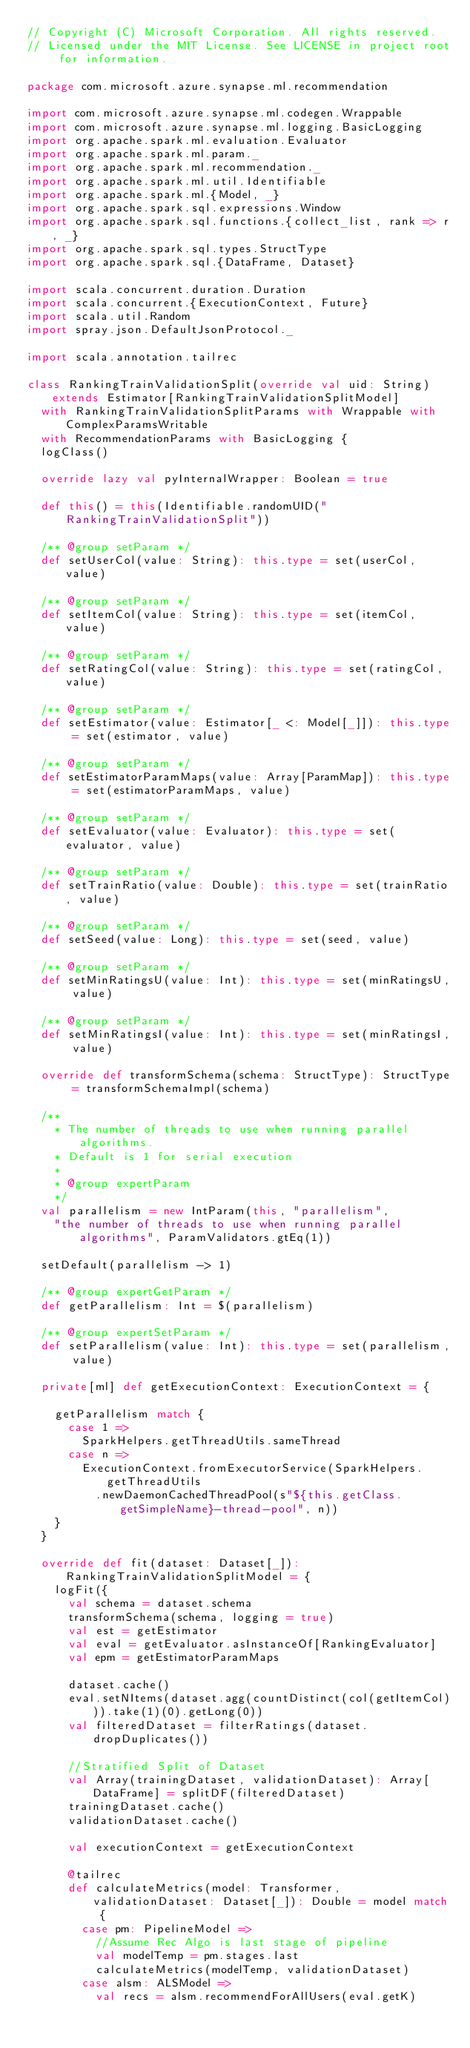Convert code to text. <code><loc_0><loc_0><loc_500><loc_500><_Scala_>// Copyright (C) Microsoft Corporation. All rights reserved.
// Licensed under the MIT License. See LICENSE in project root for information.

package com.microsoft.azure.synapse.ml.recommendation

import com.microsoft.azure.synapse.ml.codegen.Wrappable
import com.microsoft.azure.synapse.ml.logging.BasicLogging
import org.apache.spark.ml.evaluation.Evaluator
import org.apache.spark.ml.param._
import org.apache.spark.ml.recommendation._
import org.apache.spark.ml.util.Identifiable
import org.apache.spark.ml.{Model, _}
import org.apache.spark.sql.expressions.Window
import org.apache.spark.sql.functions.{collect_list, rank => r, _}
import org.apache.spark.sql.types.StructType
import org.apache.spark.sql.{DataFrame, Dataset}

import scala.concurrent.duration.Duration
import scala.concurrent.{ExecutionContext, Future}
import scala.util.Random
import spray.json.DefaultJsonProtocol._

import scala.annotation.tailrec

class RankingTrainValidationSplit(override val uid: String) extends Estimator[RankingTrainValidationSplitModel]
  with RankingTrainValidationSplitParams with Wrappable with ComplexParamsWritable
  with RecommendationParams with BasicLogging {
  logClass()

  override lazy val pyInternalWrapper: Boolean = true

  def this() = this(Identifiable.randomUID("RankingTrainValidationSplit"))

  /** @group setParam */
  def setUserCol(value: String): this.type = set(userCol, value)

  /** @group setParam */
  def setItemCol(value: String): this.type = set(itemCol, value)

  /** @group setParam */
  def setRatingCol(value: String): this.type = set(ratingCol, value)

  /** @group setParam */
  def setEstimator(value: Estimator[_ <: Model[_]]): this.type = set(estimator, value)

  /** @group setParam */
  def setEstimatorParamMaps(value: Array[ParamMap]): this.type = set(estimatorParamMaps, value)

  /** @group setParam */
  def setEvaluator(value: Evaluator): this.type = set(evaluator, value)

  /** @group setParam */
  def setTrainRatio(value: Double): this.type = set(trainRatio, value)

  /** @group setParam */
  def setSeed(value: Long): this.type = set(seed, value)

  /** @group setParam */
  def setMinRatingsU(value: Int): this.type = set(minRatingsU, value)

  /** @group setParam */
  def setMinRatingsI(value: Int): this.type = set(minRatingsI, value)

  override def transformSchema(schema: StructType): StructType = transformSchemaImpl(schema)

  /**
    * The number of threads to use when running parallel algorithms.
    * Default is 1 for serial execution
    *
    * @group expertParam
    */
  val parallelism = new IntParam(this, "parallelism",
    "the number of threads to use when running parallel algorithms", ParamValidators.gtEq(1))

  setDefault(parallelism -> 1)

  /** @group expertGetParam */
  def getParallelism: Int = $(parallelism)

  /** @group expertSetParam */
  def setParallelism(value: Int): this.type = set(parallelism, value)

  private[ml] def getExecutionContext: ExecutionContext = {

    getParallelism match {
      case 1 =>
        SparkHelpers.getThreadUtils.sameThread
      case n =>
        ExecutionContext.fromExecutorService(SparkHelpers.getThreadUtils
          .newDaemonCachedThreadPool(s"${this.getClass.getSimpleName}-thread-pool", n))
    }
  }

  override def fit(dataset: Dataset[_]): RankingTrainValidationSplitModel = {
    logFit({
      val schema = dataset.schema
      transformSchema(schema, logging = true)
      val est = getEstimator
      val eval = getEvaluator.asInstanceOf[RankingEvaluator]
      val epm = getEstimatorParamMaps

      dataset.cache()
      eval.setNItems(dataset.agg(countDistinct(col(getItemCol))).take(1)(0).getLong(0))
      val filteredDataset = filterRatings(dataset.dropDuplicates())

      //Stratified Split of Dataset
      val Array(trainingDataset, validationDataset): Array[DataFrame] = splitDF(filteredDataset)
      trainingDataset.cache()
      validationDataset.cache()

      val executionContext = getExecutionContext

      @tailrec
      def calculateMetrics(model: Transformer, validationDataset: Dataset[_]): Double = model match {
        case pm: PipelineModel =>
          //Assume Rec Algo is last stage of pipeline
          val modelTemp = pm.stages.last
          calculateMetrics(modelTemp, validationDataset)
        case alsm: ALSModel =>
          val recs = alsm.recommendForAllUsers(eval.getK)</code> 